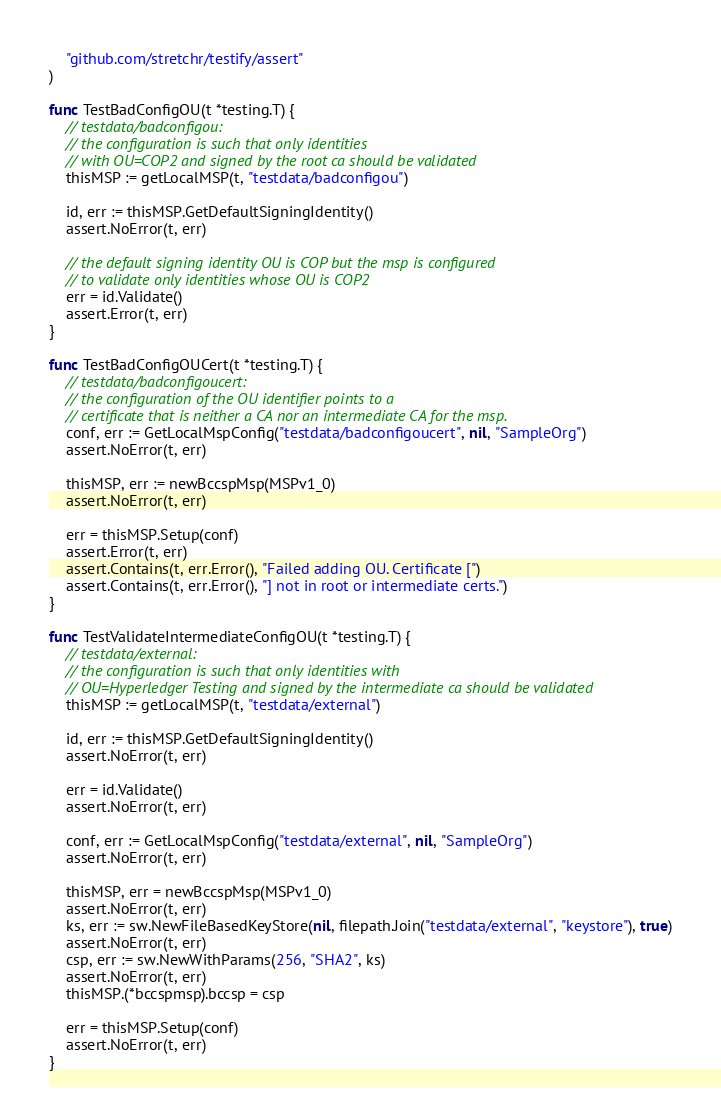<code> <loc_0><loc_0><loc_500><loc_500><_Go_>	"github.com/stretchr/testify/assert"
)

func TestBadConfigOU(t *testing.T) {
	// testdata/badconfigou:
	// the configuration is such that only identities
	// with OU=COP2 and signed by the root ca should be validated
	thisMSP := getLocalMSP(t, "testdata/badconfigou")

	id, err := thisMSP.GetDefaultSigningIdentity()
	assert.NoError(t, err)

	// the default signing identity OU is COP but the msp is configured
	// to validate only identities whose OU is COP2
	err = id.Validate()
	assert.Error(t, err)
}

func TestBadConfigOUCert(t *testing.T) {
	// testdata/badconfigoucert:
	// the configuration of the OU identifier points to a
	// certificate that is neither a CA nor an intermediate CA for the msp.
	conf, err := GetLocalMspConfig("testdata/badconfigoucert", nil, "SampleOrg")
	assert.NoError(t, err)

	thisMSP, err := newBccspMsp(MSPv1_0)
	assert.NoError(t, err)

	err = thisMSP.Setup(conf)
	assert.Error(t, err)
	assert.Contains(t, err.Error(), "Failed adding OU. Certificate [")
	assert.Contains(t, err.Error(), "] not in root or intermediate certs.")
}

func TestValidateIntermediateConfigOU(t *testing.T) {
	// testdata/external:
	// the configuration is such that only identities with
	// OU=Hyperledger Testing and signed by the intermediate ca should be validated
	thisMSP := getLocalMSP(t, "testdata/external")

	id, err := thisMSP.GetDefaultSigningIdentity()
	assert.NoError(t, err)

	err = id.Validate()
	assert.NoError(t, err)

	conf, err := GetLocalMspConfig("testdata/external", nil, "SampleOrg")
	assert.NoError(t, err)

	thisMSP, err = newBccspMsp(MSPv1_0)
	assert.NoError(t, err)
	ks, err := sw.NewFileBasedKeyStore(nil, filepath.Join("testdata/external", "keystore"), true)
	assert.NoError(t, err)
	csp, err := sw.NewWithParams(256, "SHA2", ks)
	assert.NoError(t, err)
	thisMSP.(*bccspmsp).bccsp = csp

	err = thisMSP.Setup(conf)
	assert.NoError(t, err)
}
</code> 